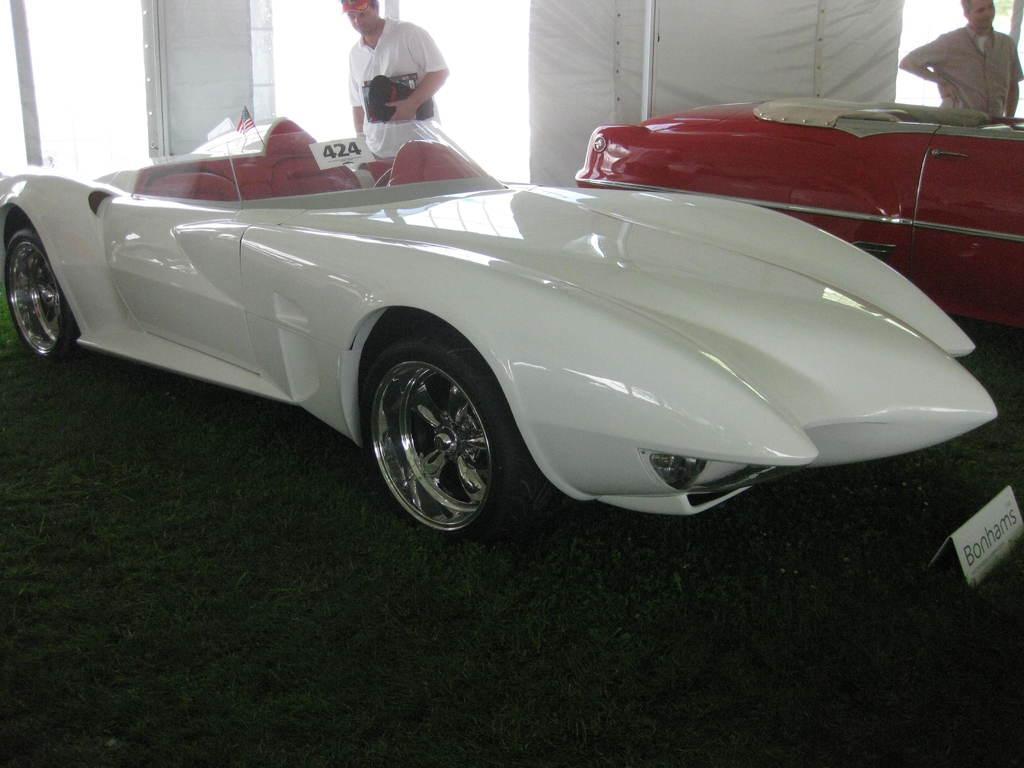In one or two sentences, can you explain what this image depicts? In this image I can see two cars which are in white and red color. To the side there are two people standing and wearing the white and ash color dresses. I can see one person holding the black color object. In the back there is a curtain. And I can see the board in the front of the car. 